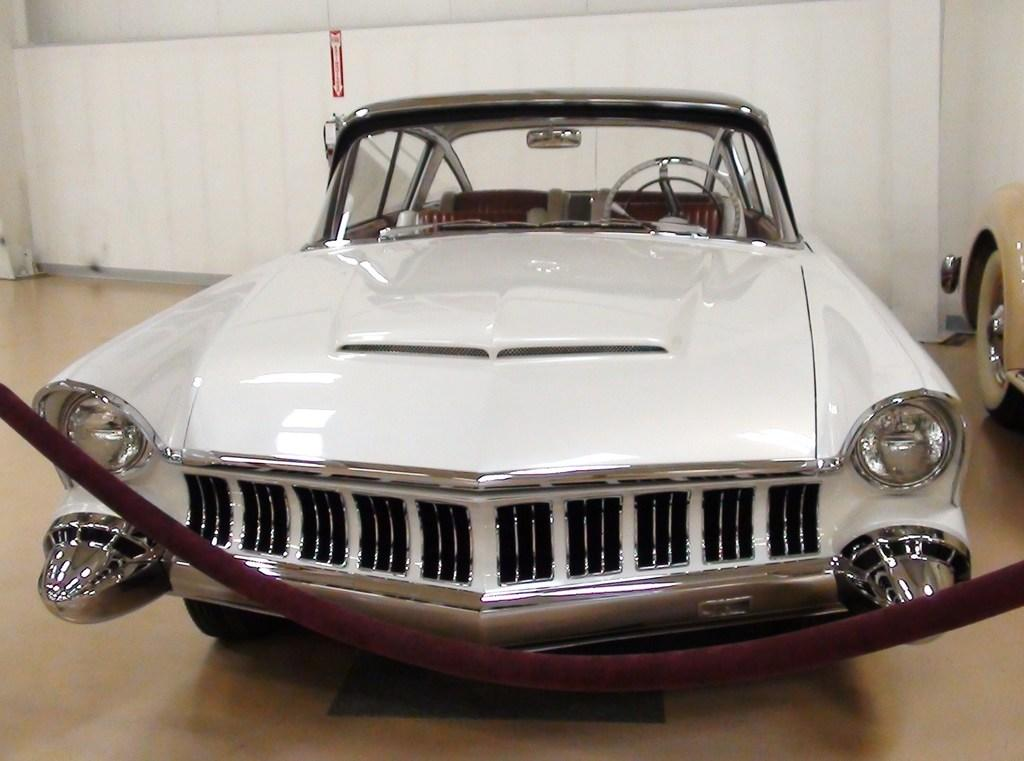What type of vehicles can be seen in the image? There are cars in the image. What is visible in the background of the image? There is a wall in the background of the image. What type of scent can be detected from the cars in the image? There is no information about the scent of the cars in the image, as it is a visual medium. 